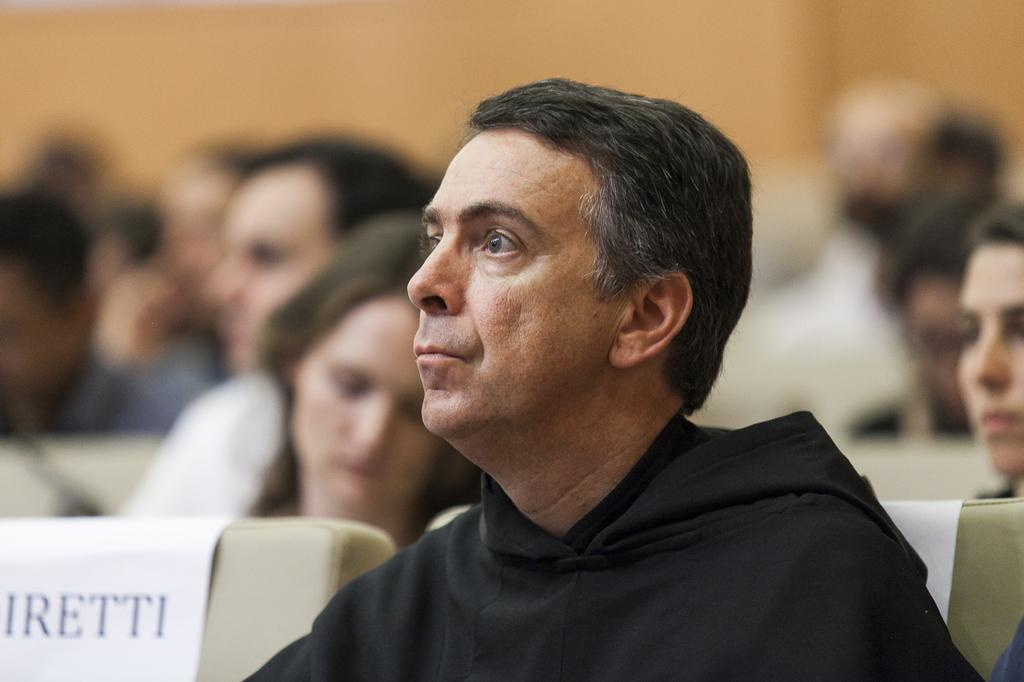What is the main subject of the image? The main subject of the image is a group of people. What are the people doing in the image? The people are sitting on a chair in the image. Is there anything else notable about the chair in the image? Yes, there is a paper stuck on a chair in the image. What color is the thread used to sew the ball in the image? There is no thread or ball present in the image. 